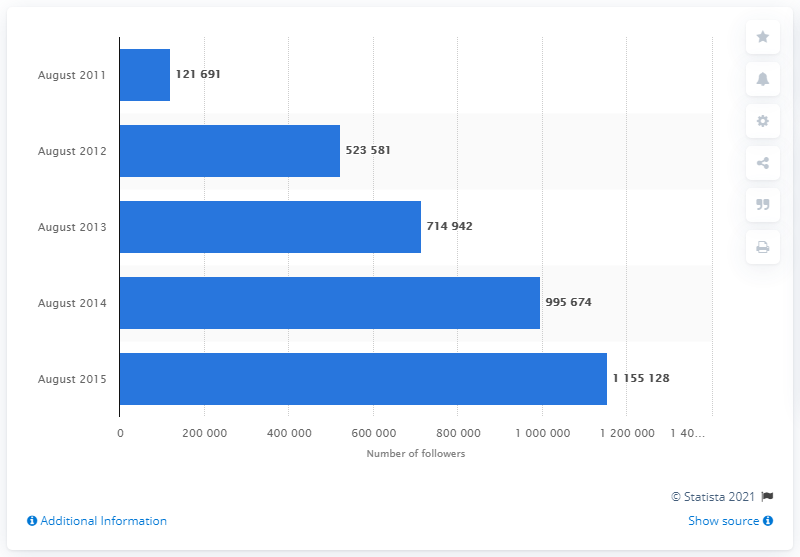Indicate a few pertinent items in this graphic. In August 2011, Sainsbury's had 121,691 followers. 